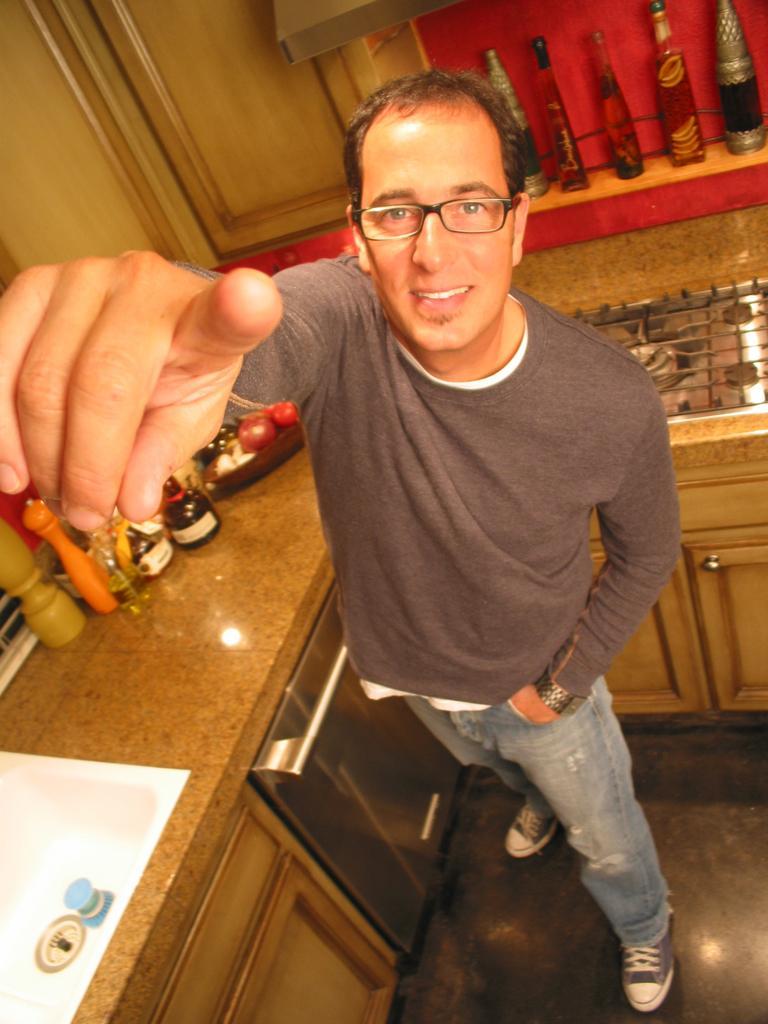Could you give a brief overview of what you see in this image? In this image we can see a man wearing specs is standing. Near to him there is a platform with cupboards. On the platform there is a stove, bottles and many other items. In the back there is a wall. Near to that there are bottles. 